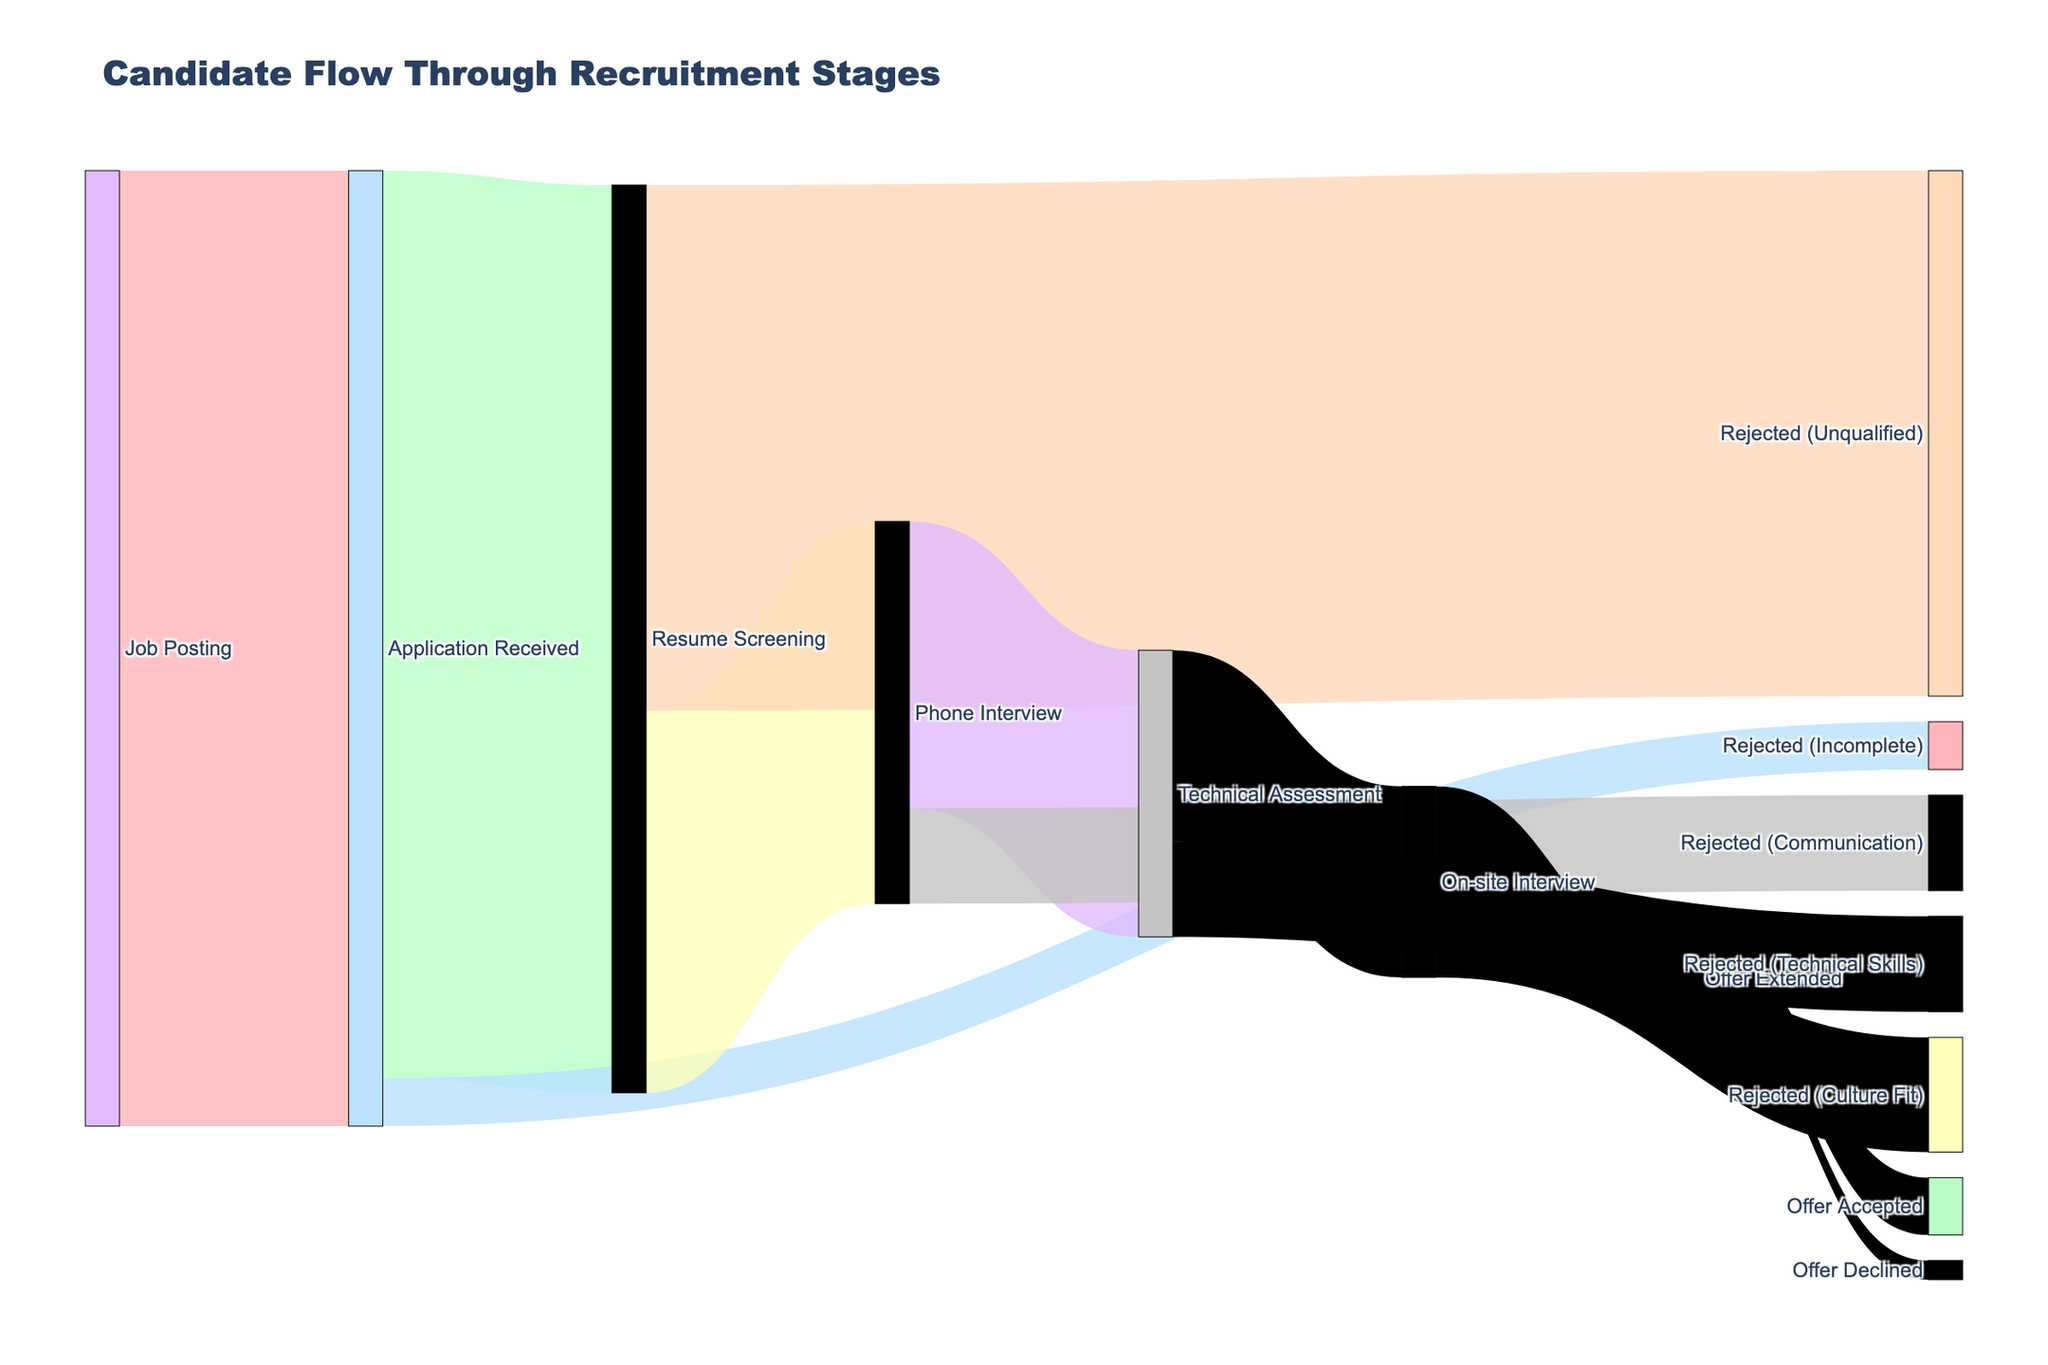How many candidates applied for the software developer position? According to the Sankey diagram, the number of candidates who applied can be found under the "Application Received" node.
Answer: 1000 What is the rejection rate at the Resume Screening stage? The rejection rate at the Resume Screening stage can be calculated by dividing the number of rejections (550) by the total number of candidates that reached that stage (950). Hence, 550/950 equals approximately 57.9%.
Answer: 57.9% How many candidates were rejected after the On-site Interview due to culture fit? The number of candidates rejected after the On-site Interview due to culture fit can be found under the "Rejected (Culture Fit)" target from the "On-site Interview" node.
Answer: 120 What is the total number of candidates who eventually received a job offer? The total number of candidates who received an offer can be calculated by summing the values from the “Offer Extended” node to “Offer Accepted” and “Offer Declined.” Thus, 60 + 20 equals 80 candidates.
Answer: 80 How many candidates were rejected due to technical skills after the Technical Assessment stage? By looking at the "Rejected (Technical Skills)" target from the "Technical Assessment" node, we can see the number of candidates rejected due to technical skills.
Answer: 100 What is the overall success rate from application to offer acceptance? To find the success rate from application to offer acceptance, divide the number of offers accepted (60) by the initial number of applications received (1000). Thus, 60/1000 equals 6%.
Answer: 6% Which stage sees the highest number of candidates being rejected? By comparing all the rejection figures, the highest number of rejections occurs at the Resume Screening stage with 550 rejections under "Rejected (Unqualified)."
Answer: Resume Screening Compare the number of candidates who moved from Phone Interview to Technical Assessment versus those who were rejected due to communication issues. 300 candidates moved from Phone Interview to Technical Assessment, while 100 were rejected due to communication issues. 300 is greater than 100.
Answer: More candidates moved to Technical Assessment What is the primary reason for candidate rejection during the recruitment process? By analyzing the reasons for rejection at each stage, the primary reason is at the Resume Screening stage under "Rejected (Unqualified)" with 550 candidates.
Answer: Unqualified 